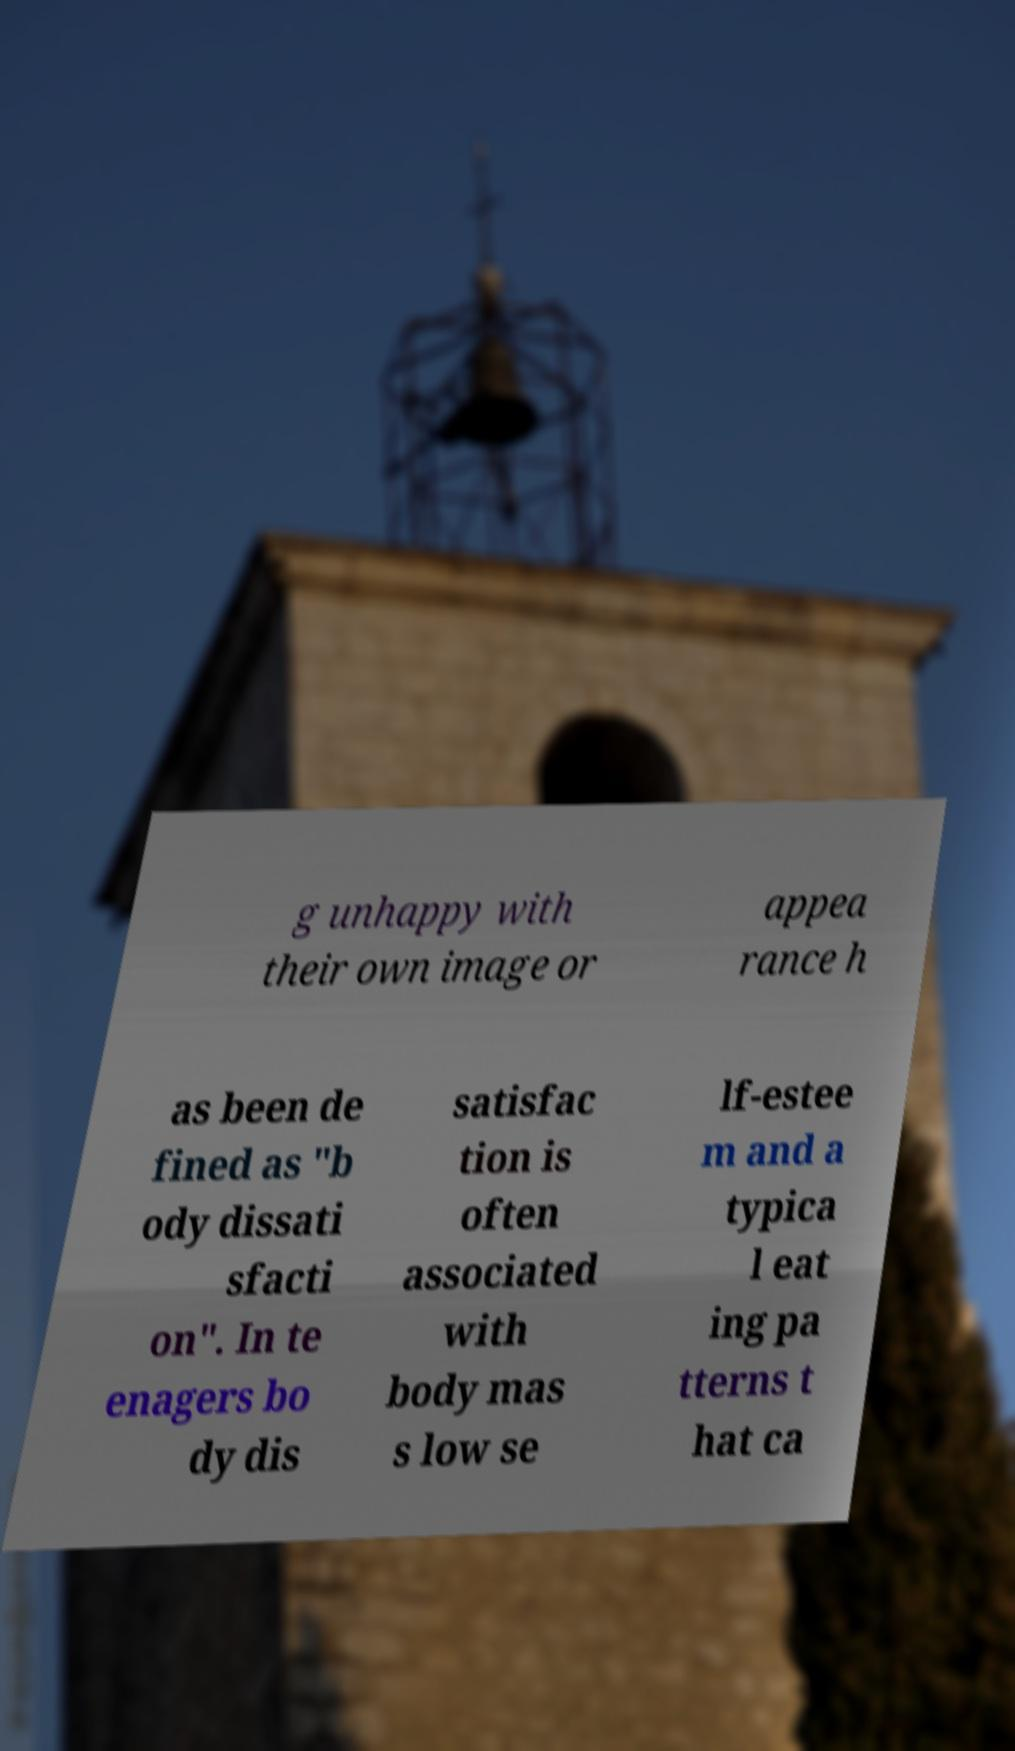Can you read and provide the text displayed in the image?This photo seems to have some interesting text. Can you extract and type it out for me? g unhappy with their own image or appea rance h as been de fined as "b ody dissati sfacti on". In te enagers bo dy dis satisfac tion is often associated with body mas s low se lf-estee m and a typica l eat ing pa tterns t hat ca 